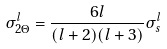<formula> <loc_0><loc_0><loc_500><loc_500>\sigma _ { 2 \Theta } ^ { l } = \frac { 6 l } { ( l + 2 ) ( l + 3 ) } \sigma _ { s } ^ { l }</formula> 